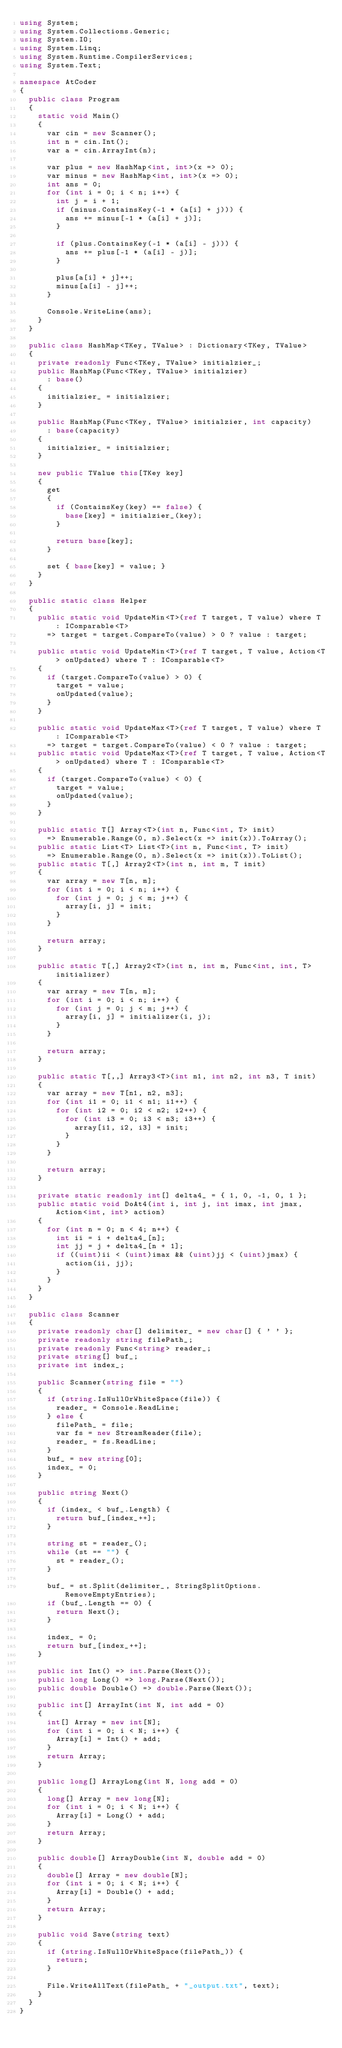<code> <loc_0><loc_0><loc_500><loc_500><_C#_>using System;
using System.Collections.Generic;
using System.IO;
using System.Linq;
using System.Runtime.CompilerServices;
using System.Text;

namespace AtCoder
{
	public class Program
	{
		static void Main()
		{
			var cin = new Scanner();
			int n = cin.Int();
			var a = cin.ArrayInt(n);

			var plus = new HashMap<int, int>(x => 0);
			var minus = new HashMap<int, int>(x => 0);
			int ans = 0;
			for (int i = 0; i < n; i++) {
				int j = i + 1;
				if (minus.ContainsKey(-1 * (a[i] + j))) {
					ans += minus[-1 * (a[i] + j)];
				}

				if (plus.ContainsKey(-1 * (a[i] - j))) {
					ans += plus[-1 * (a[i] - j)];
				}

				plus[a[i] + j]++;
				minus[a[i] - j]++;
			}

			Console.WriteLine(ans);
		}
	}

	public class HashMap<TKey, TValue> : Dictionary<TKey, TValue>
	{
		private readonly Func<TKey, TValue> initialzier_;
		public HashMap(Func<TKey, TValue> initialzier)
			: base()
		{
			initialzier_ = initialzier;
		}

		public HashMap(Func<TKey, TValue> initialzier, int capacity)
			: base(capacity)
		{
			initialzier_ = initialzier;
		}

		new public TValue this[TKey key]
		{
			get
			{
				if (ContainsKey(key) == false) {
					base[key] = initialzier_(key);
				}

				return base[key];
			}

			set { base[key] = value; }
		}
	}

	public static class Helper
	{
		public static void UpdateMin<T>(ref T target, T value) where T : IComparable<T>
			=> target = target.CompareTo(value) > 0 ? value : target;

		public static void UpdateMin<T>(ref T target, T value, Action<T> onUpdated) where T : IComparable<T>
		{
			if (target.CompareTo(value) > 0) {
				target = value;
				onUpdated(value);
			}
		}

		public static void UpdateMax<T>(ref T target, T value) where T : IComparable<T>
			=> target = target.CompareTo(value) < 0 ? value : target;
		public static void UpdateMax<T>(ref T target, T value, Action<T> onUpdated) where T : IComparable<T>
		{
			if (target.CompareTo(value) < 0) {
				target = value;
				onUpdated(value);
			}
		}

		public static T[] Array<T>(int n, Func<int, T> init)
			=> Enumerable.Range(0, n).Select(x => init(x)).ToArray();
		public static List<T> List<T>(int n, Func<int, T> init)
			=> Enumerable.Range(0, n).Select(x => init(x)).ToList();
		public static T[,] Array2<T>(int n, int m, T init)
		{
			var array = new T[n, m];
			for (int i = 0; i < n; i++) {
				for (int j = 0; j < m; j++) {
					array[i, j] = init;
				}
			}

			return array;
		}

		public static T[,] Array2<T>(int n, int m, Func<int, int, T> initializer)
		{
			var array = new T[n, m];
			for (int i = 0; i < n; i++) {
				for (int j = 0; j < m; j++) {
					array[i, j] = initializer(i, j);
				}
			}

			return array;
		}

		public static T[,,] Array3<T>(int n1, int n2, int n3, T init)
		{
			var array = new T[n1, n2, n3];
			for (int i1 = 0; i1 < n1; i1++) {
				for (int i2 = 0; i2 < n2; i2++) {
					for (int i3 = 0; i3 < n3; i3++) {
						array[i1, i2, i3] = init;
					}
				}
			}

			return array;
		}

		private static readonly int[] delta4_ = { 1, 0, -1, 0, 1 };
		public static void DoAt4(int i, int j, int imax, int jmax, Action<int, int> action)
		{
			for (int n = 0; n < 4; n++) {
				int ii = i + delta4_[n];
				int jj = j + delta4_[n + 1];
				if ((uint)ii < (uint)imax && (uint)jj < (uint)jmax) {
					action(ii, jj);
				}
			}
		}
	}

	public class Scanner
	{
		private readonly char[] delimiter_ = new char[] { ' ' };
		private readonly string filePath_;
		private readonly Func<string> reader_;
		private string[] buf_;
		private int index_;

		public Scanner(string file = "")
		{
			if (string.IsNullOrWhiteSpace(file)) {
				reader_ = Console.ReadLine;
			} else {
				filePath_ = file;
				var fs = new StreamReader(file);
				reader_ = fs.ReadLine;
			}
			buf_ = new string[0];
			index_ = 0;
		}

		public string Next()
		{
			if (index_ < buf_.Length) {
				return buf_[index_++];
			}

			string st = reader_();
			while (st == "") {
				st = reader_();
			}

			buf_ = st.Split(delimiter_, StringSplitOptions.RemoveEmptyEntries);
			if (buf_.Length == 0) {
				return Next();
			}

			index_ = 0;
			return buf_[index_++];
		}

		public int Int() => int.Parse(Next());
		public long Long() => long.Parse(Next());
		public double Double() => double.Parse(Next());

		public int[] ArrayInt(int N, int add = 0)
		{
			int[] Array = new int[N];
			for (int i = 0; i < N; i++) {
				Array[i] = Int() + add;
			}
			return Array;
		}

		public long[] ArrayLong(int N, long add = 0)
		{
			long[] Array = new long[N];
			for (int i = 0; i < N; i++) {
				Array[i] = Long() + add;
			}
			return Array;
		}

		public double[] ArrayDouble(int N, double add = 0)
		{
			double[] Array = new double[N];
			for (int i = 0; i < N; i++) {
				Array[i] = Double() + add;
			}
			return Array;
		}

		public void Save(string text)
		{
			if (string.IsNullOrWhiteSpace(filePath_)) {
				return;
			}

			File.WriteAllText(filePath_ + "_output.txt", text);
		}
	}
}
</code> 